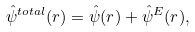<formula> <loc_0><loc_0><loc_500><loc_500>\hat { \psi } ^ { t o t a l } ( { r } ) = \hat { \psi } ( { r } ) + \hat { \psi } ^ { E } ( { r } ) ,</formula> 